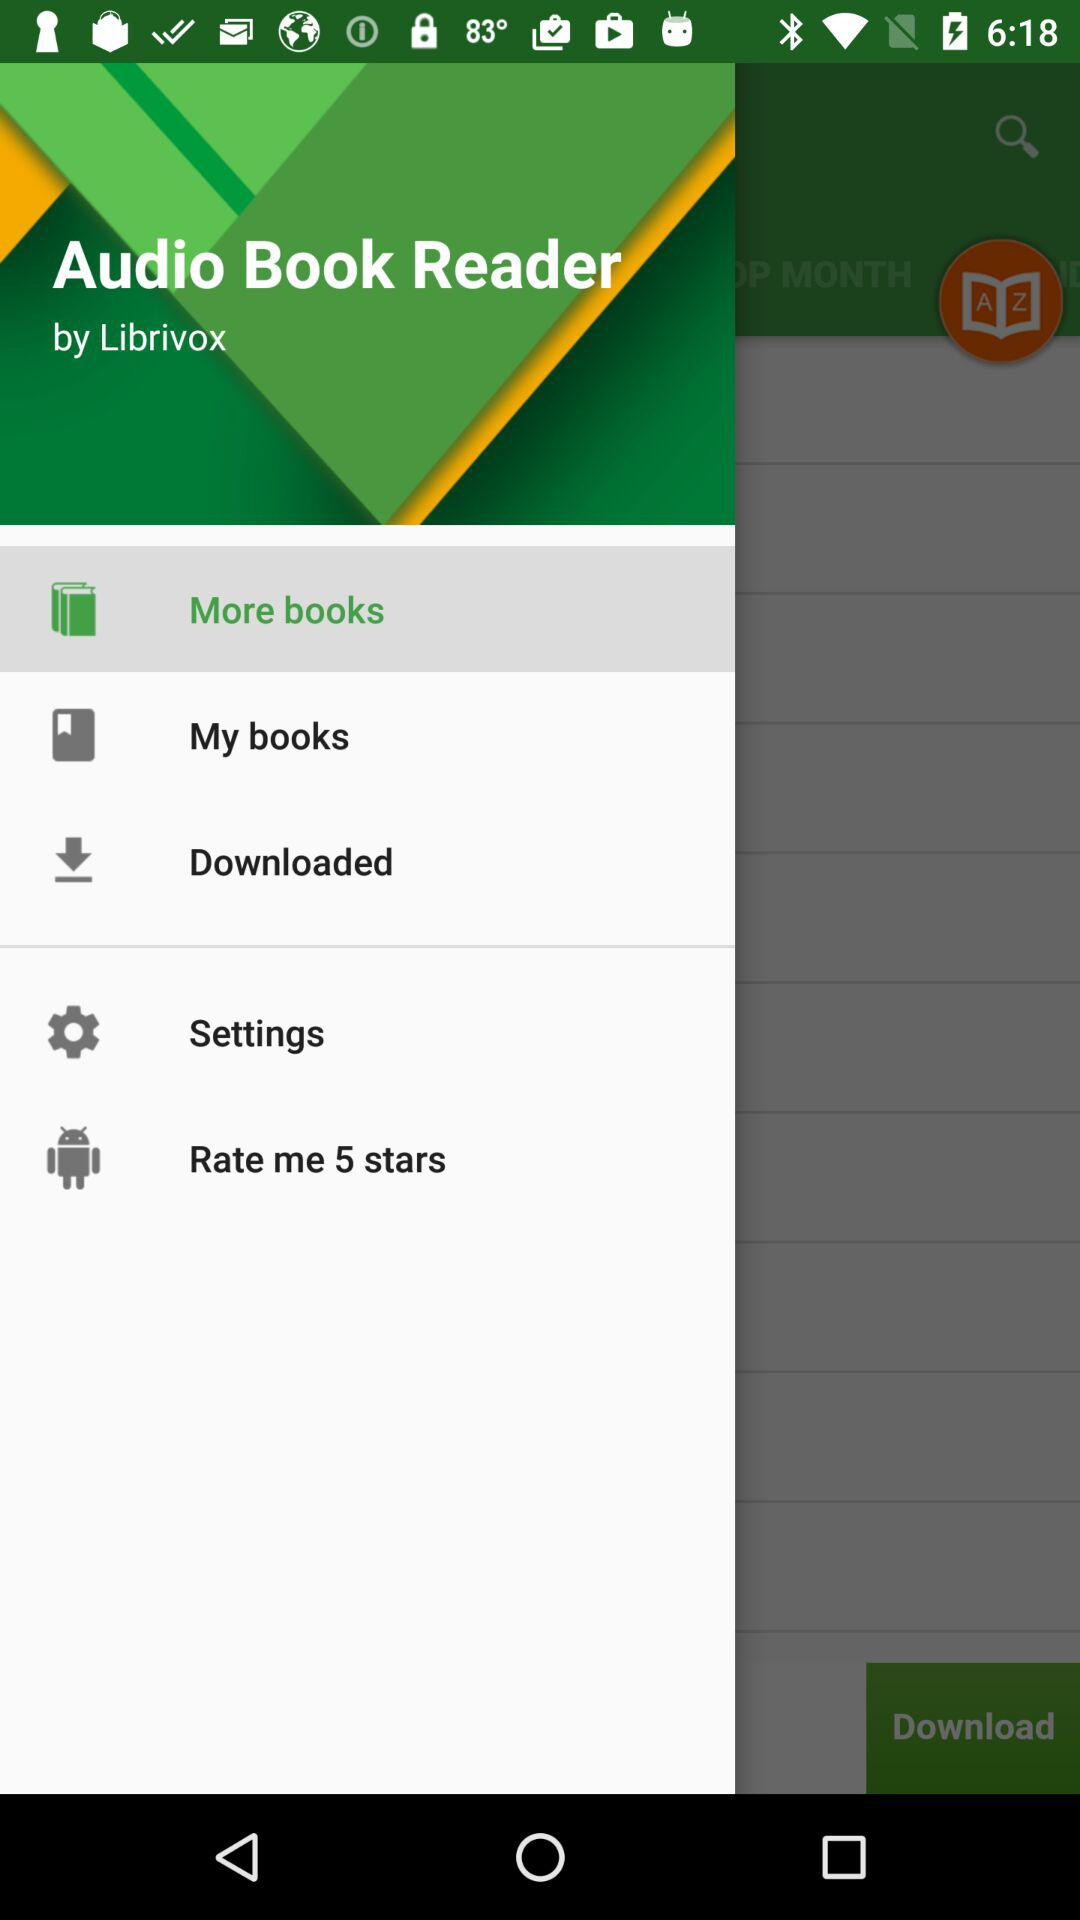What is the name of the application? The name of the application is "Audio Book Reader". 